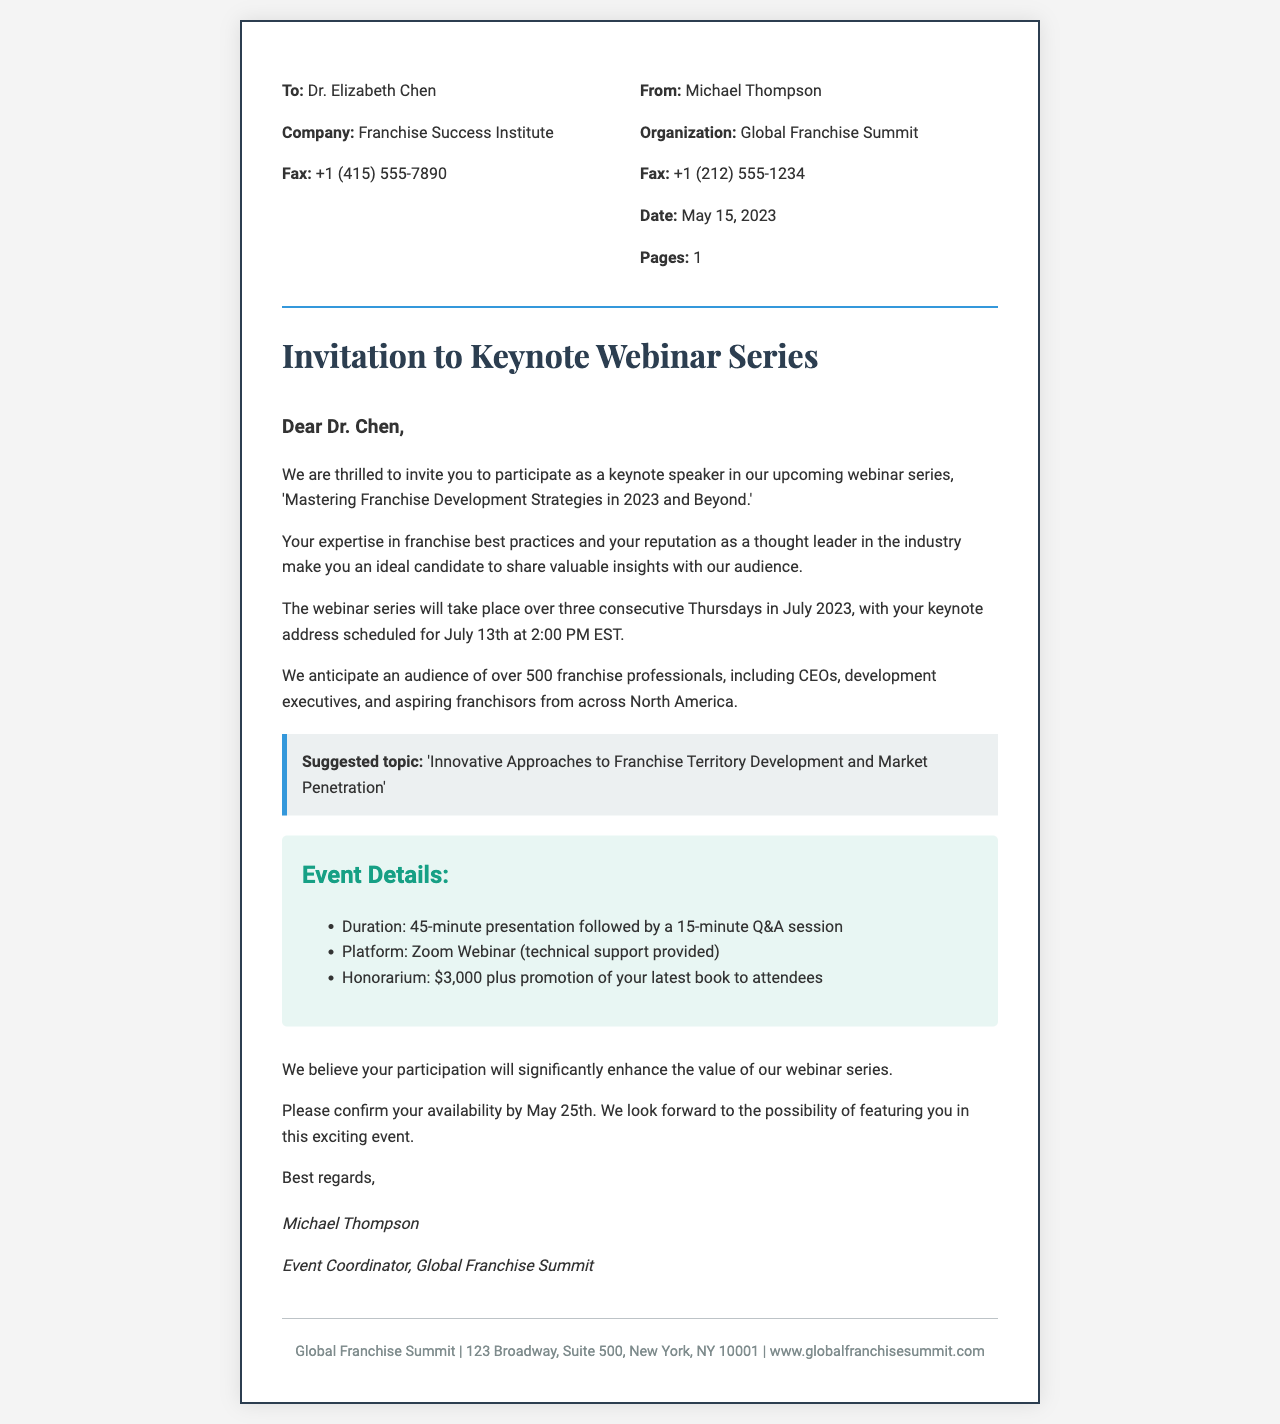What is the name of the event for which the invitation is sent? The name of the event is mentioned in the document as 'Mastering Franchise Development Strategies in 2023 and Beyond.'
Answer: Mastering Franchise Development Strategies in 2023 and Beyond Who is the intended recipient of the fax? The fax explicitly states that it is addressed to Dr. Elizabeth Chen.
Answer: Dr. Elizabeth Chen What is the scheduled date and time for the keynote address? The document specifies the keynote address is scheduled for July 13th at 2:00 PM EST.
Answer: July 13th at 2:00 PM EST What is the honorarium offered for the keynote speaker? The fax includes that the honorarium for the keynote speaker is $3,000.
Answer: $3,000 How long will the presentation last? The document states that the presentation will last for 45 minutes.
Answer: 45 minutes What is the primary platform used for the webinar? The invitation indicates that the platform for the webinar is Zoom Webinar.
Answer: Zoom Webinar How many franchise professionals are anticipated to attend? The estimated audience mentioned in the document is over 500 franchise professionals.
Answer: over 500 What is the deadline for confirmation of participation? The document states that the confirmation of participation should be done by May 25th.
Answer: May 25th What is the suggested topic for the keynote address? The suggested topic mentioned in the document is 'Innovative Approaches to Franchise Territory Development and Market Penetration.'
Answer: Innovative Approaches to Franchise Territory Development and Market Penetration 